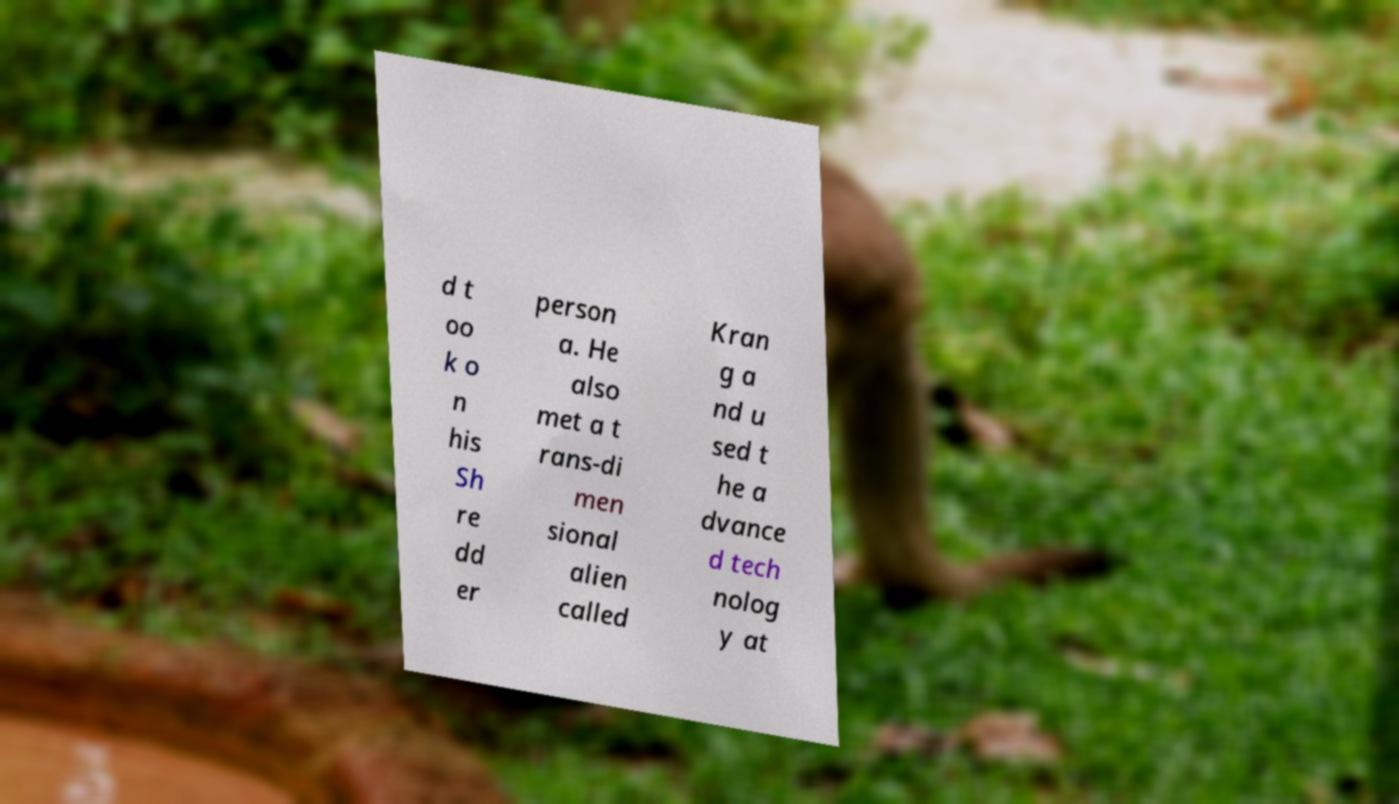Could you assist in decoding the text presented in this image and type it out clearly? d t oo k o n his Sh re dd er person a. He also met a t rans-di men sional alien called Kran g a nd u sed t he a dvance d tech nolog y at 